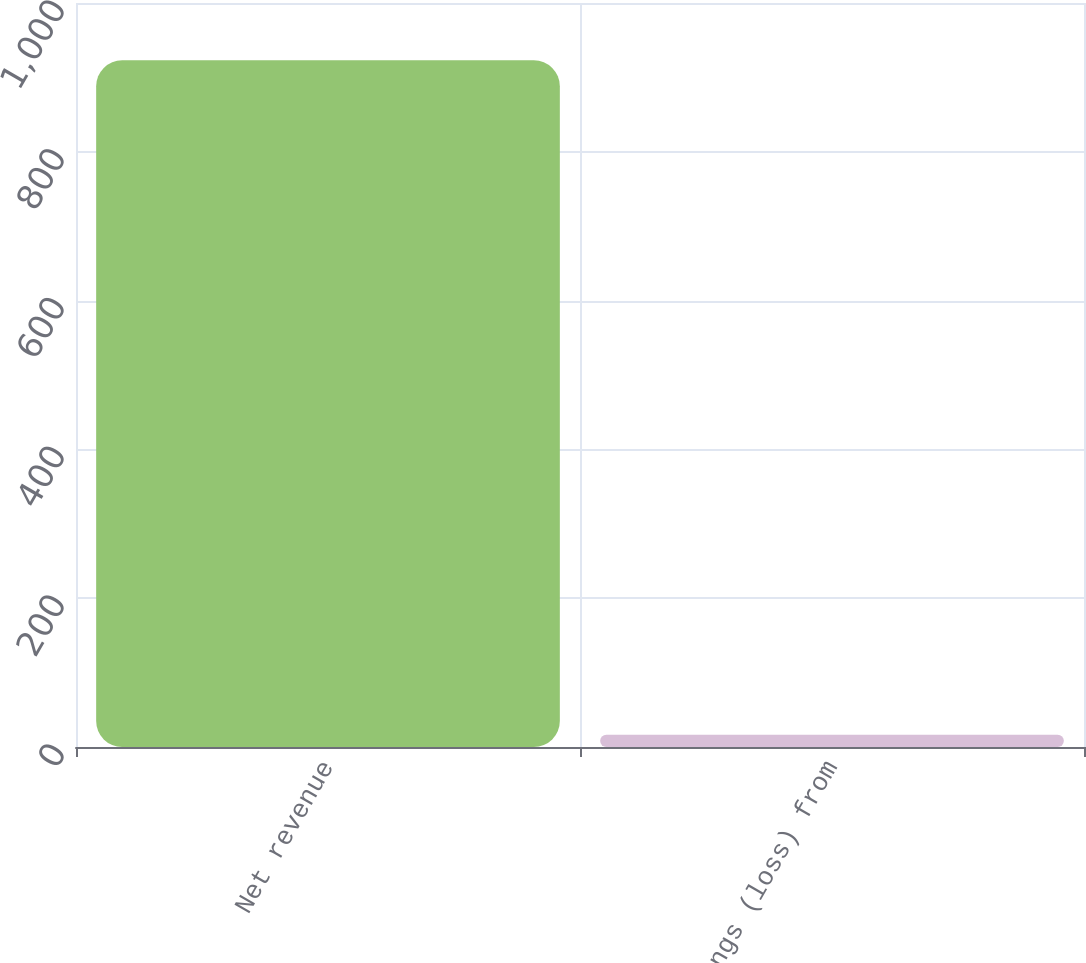Convert chart to OTSL. <chart><loc_0><loc_0><loc_500><loc_500><bar_chart><fcel>Net revenue<fcel>Earnings (loss) from<nl><fcel>923<fcel>16.5<nl></chart> 